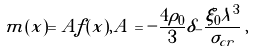Convert formula to latex. <formula><loc_0><loc_0><loc_500><loc_500>m ( x ) = A f ( x ) , A = - { \frac { 4 \rho _ { 0 } } { 3 } } \delta _ { - } { \frac { \xi _ { 0 } \lambda ^ { 3 } } { \sigma _ { c r } } } \, ,</formula> 